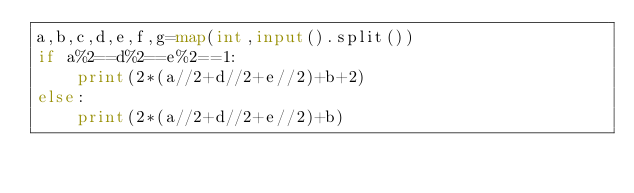<code> <loc_0><loc_0><loc_500><loc_500><_Python_>a,b,c,d,e,f,g=map(int,input().split())
if a%2==d%2==e%2==1:
    print(2*(a//2+d//2+e//2)+b+2)
else:
    print(2*(a//2+d//2+e//2)+b)</code> 